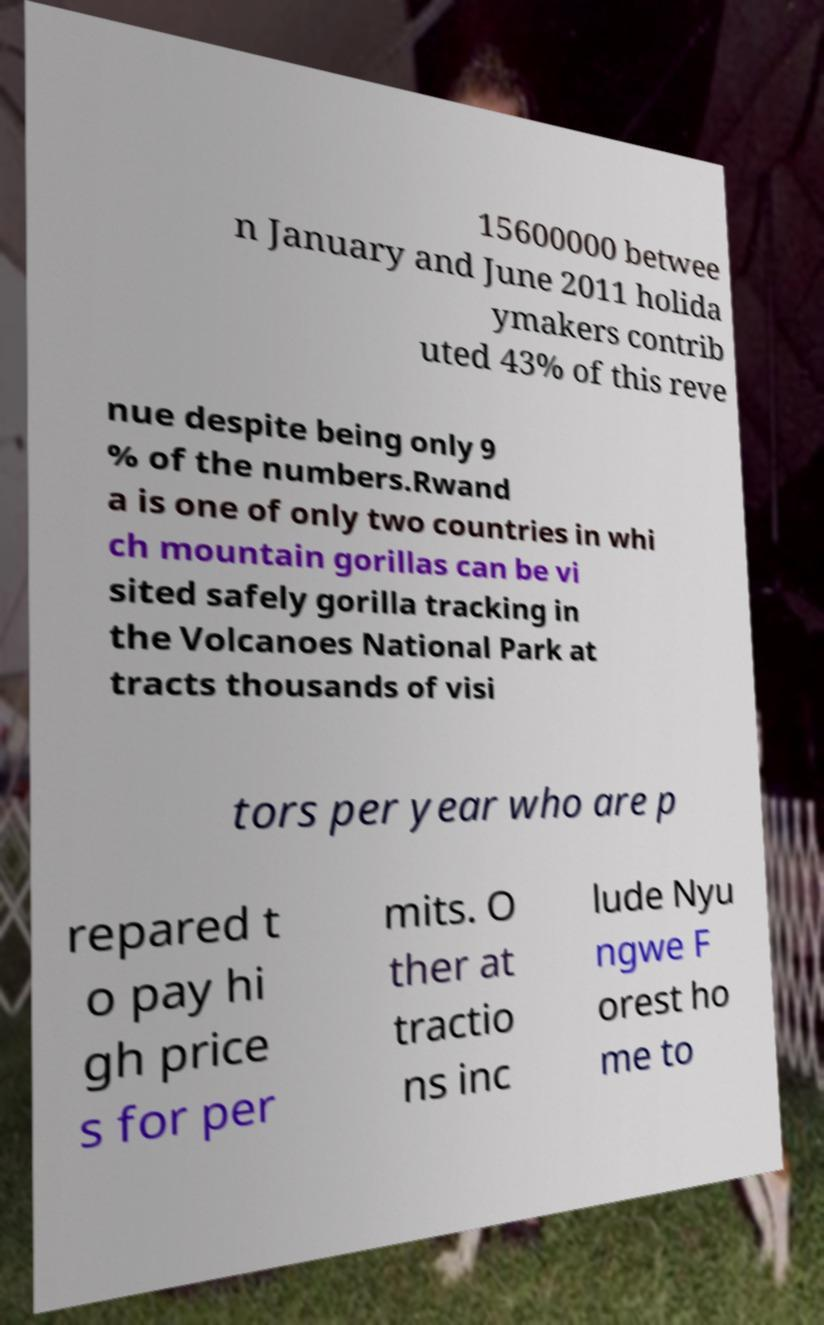Please read and relay the text visible in this image. What does it say? 15600000 betwee n January and June 2011 holida ymakers contrib uted 43% of this reve nue despite being only 9 % of the numbers.Rwand a is one of only two countries in whi ch mountain gorillas can be vi sited safely gorilla tracking in the Volcanoes National Park at tracts thousands of visi tors per year who are p repared t o pay hi gh price s for per mits. O ther at tractio ns inc lude Nyu ngwe F orest ho me to 